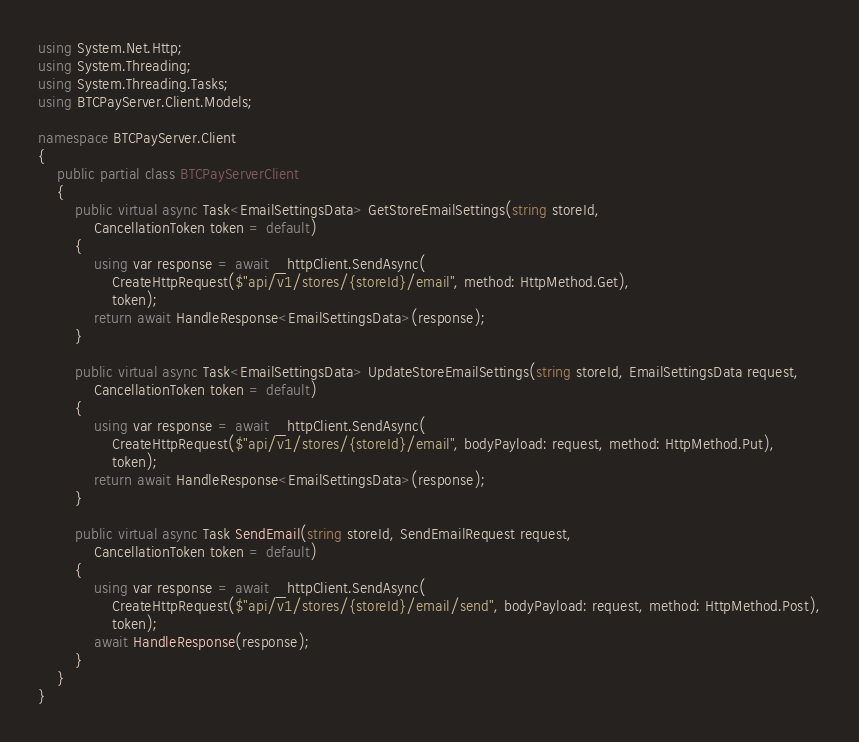Convert code to text. <code><loc_0><loc_0><loc_500><loc_500><_C#_>using System.Net.Http;
using System.Threading;
using System.Threading.Tasks;
using BTCPayServer.Client.Models;

namespace BTCPayServer.Client
{
    public partial class BTCPayServerClient
    {
        public virtual async Task<EmailSettingsData> GetStoreEmailSettings(string storeId,
            CancellationToken token = default)
        {
            using var response = await _httpClient.SendAsync(
                CreateHttpRequest($"api/v1/stores/{storeId}/email", method: HttpMethod.Get),
                token);
            return await HandleResponse<EmailSettingsData>(response);
        }

        public virtual async Task<EmailSettingsData> UpdateStoreEmailSettings(string storeId, EmailSettingsData request,
            CancellationToken token = default)
        {
            using var response = await _httpClient.SendAsync(
                CreateHttpRequest($"api/v1/stores/{storeId}/email", bodyPayload: request, method: HttpMethod.Put),
                token);
            return await HandleResponse<EmailSettingsData>(response);
        }

        public virtual async Task SendEmail(string storeId, SendEmailRequest request,
            CancellationToken token = default)
        {
            using var response = await _httpClient.SendAsync(
                CreateHttpRequest($"api/v1/stores/{storeId}/email/send", bodyPayload: request, method: HttpMethod.Post),
                token);
            await HandleResponse(response);
        }
    }
}
</code> 